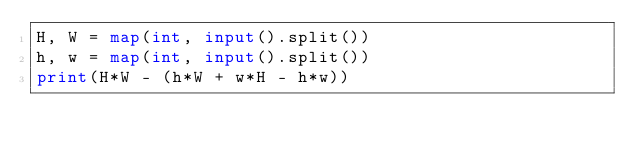<code> <loc_0><loc_0><loc_500><loc_500><_Python_>H, W = map(int, input().split())
h, w = map(int, input().split())
print(H*W - (h*W + w*H - h*w))
</code> 